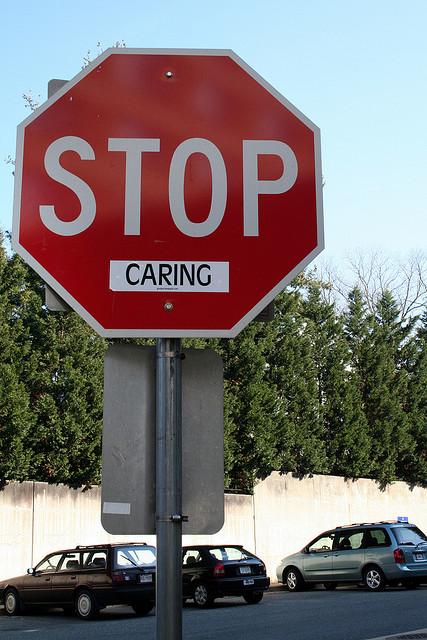Are the trees green?
Write a very short answer. Yes. How many cars are in the picture?
Concise answer only. 3. How many cars in this scene?
Write a very short answer. 3. Is this bad?
Quick response, please. Yes. 